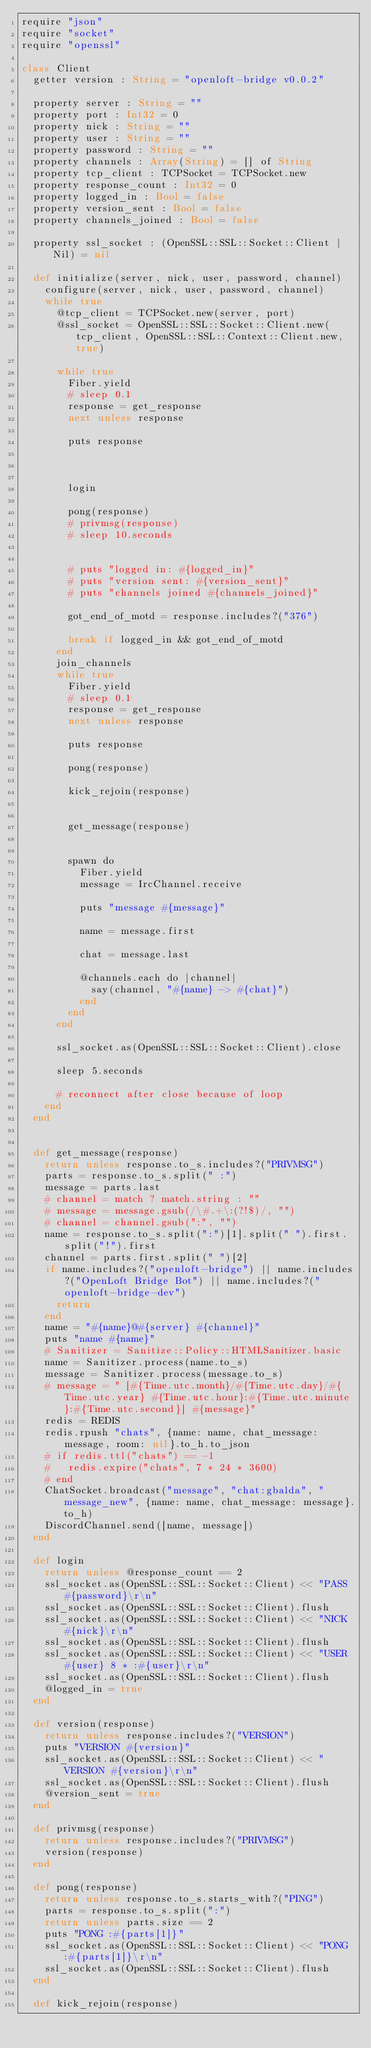Convert code to text. <code><loc_0><loc_0><loc_500><loc_500><_Crystal_>require "json"
require "socket"
require "openssl"

class Client
  getter version : String = "openloft-bridge v0.0.2"

  property server : String = ""
  property port : Int32 = 0
  property nick : String = ""
  property user : String = ""
  property password : String = ""
  property channels : Array(String) = [] of String
  property tcp_client : TCPSocket = TCPSocket.new
  property response_count : Int32 = 0
  property logged_in : Bool = false
  property version_sent : Bool = false
  property channels_joined : Bool = false

  property ssl_socket : (OpenSSL::SSL::Socket::Client | Nil) = nil
  
  def initialize(server, nick, user, password, channel)
    configure(server, nick, user, password, channel)
    while true
      @tcp_client = TCPSocket.new(server, port)
      @ssl_socket = OpenSSL::SSL::Socket::Client.new(tcp_client, OpenSSL::SSL::Context::Client.new, true)

      while true
        Fiber.yield
        # sleep 0.1
        response = get_response
        next unless response

        puts response

        

        login

        pong(response)
        # privmsg(response)
        # sleep 10.seconds
        

        # puts "logged in: #{logged_in}"
        # puts "version sent: #{version_sent}"
        # puts "channels joined #{channels_joined}"

        got_end_of_motd = response.includes?("376")

        break if logged_in && got_end_of_motd
      end
      join_channels
      while true
        Fiber.yield
        # sleep 0.1
        response = get_response
        next unless response

        puts response

        pong(response)

        kick_rejoin(response)


        get_message(response)
        

        spawn do
          Fiber.yield
          message = IrcChannel.receive

          puts "message #{message}"

          name = message.first

          chat = message.last

          @channels.each do |channel|
            say(channel, "#{name} -> #{chat}")
          end
        end
      end
      
      ssl_socket.as(OpenSSL::SSL::Socket::Client).close

      sleep 5.seconds

      # reconnect after close because of loop
    end
  end


  def get_message(response)
    return unless response.to_s.includes?("PRIVMSG")
    parts = response.to_s.split(" :")
    message = parts.last
    # channel = match ? match.string : ""
    # message = message.gsub(/\#.+\:(?!$)/, "")
    # channel = channel.gsub(":", "")
    name = response.to_s.split(":")[1].split(" ").first.split("!").first
    channel = parts.first.split(" ")[2]
    if name.includes?("openloft-bridge") || name.includes?("OpenLoft Bridge Bot") || name.includes?("openloft-bridge-dev")
      return
    end
    name = "#{name}@#{server} #{channel}"
    puts "name #{name}"
    # Sanitizer = Sanitize::Policy::HTMLSanitizer.basic
    name = Sanitizer.process(name.to_s)
    message = Sanitizer.process(message.to_s)
    # message = " [#{Time.utc.month}/#{Time.utc.day}/#{Time.utc.year} #{Time.utc.hour}:#{Time.utc.minute}:#{Time.utc.second}] #{message}"
    redis = REDIS
    redis.rpush "chats", {name: name, chat_message: message, room: nil}.to_h.to_json
    # if redis.ttl("chats") == -1
    #   redis.expire("chats", 7 * 24 * 3600)
    # end
    ChatSocket.broadcast("message", "chat:gbalda", "message_new", {name: name, chat_message: message}.to_h)
    DiscordChannel.send([name, message])
  end

  def login
    return unless @response_count == 2
    ssl_socket.as(OpenSSL::SSL::Socket::Client) << "PASS #{password}\r\n"
    ssl_socket.as(OpenSSL::SSL::Socket::Client).flush
    ssl_socket.as(OpenSSL::SSL::Socket::Client) << "NICK #{nick}\r\n"
    ssl_socket.as(OpenSSL::SSL::Socket::Client).flush
    ssl_socket.as(OpenSSL::SSL::Socket::Client) << "USER #{user} 8 * :#{user}\r\n"
    ssl_socket.as(OpenSSL::SSL::Socket::Client).flush
    @logged_in = true
  end

  def version(response)
    return unless response.includes?("VERSION")
    puts "VERSION #{version}"
    ssl_socket.as(OpenSSL::SSL::Socket::Client) << "VERSION #{version}\r\n"
    ssl_socket.as(OpenSSL::SSL::Socket::Client).flush
    @version_sent = true
  end

  def privmsg(response)
    return unless response.includes?("PRIVMSG")
    version(response)
  end

  def pong(response)
    return unless response.to_s.starts_with?("PING")
    parts = response.to_s.split(":")
    return unless parts.size == 2
    puts "PONG :#{parts[1]}"
    ssl_socket.as(OpenSSL::SSL::Socket::Client) << "PONG :#{parts[1]}\r\n"
    ssl_socket.as(OpenSSL::SSL::Socket::Client).flush
  end

  def kick_rejoin(response)
    </code> 